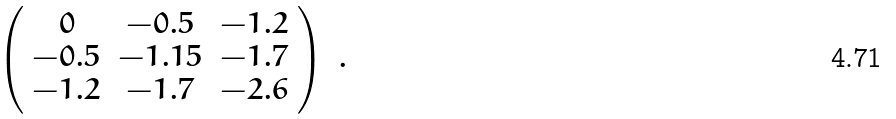Convert formula to latex. <formula><loc_0><loc_0><loc_500><loc_500>\left ( \begin{array} { c c c } 0 & - 0 . 5 & - 1 . 2 \\ - 0 . 5 & - 1 . 1 5 & - 1 . 7 \\ - 1 . 2 & - 1 . 7 & - 2 . 6 \\ \end{array} \right ) \ .</formula> 